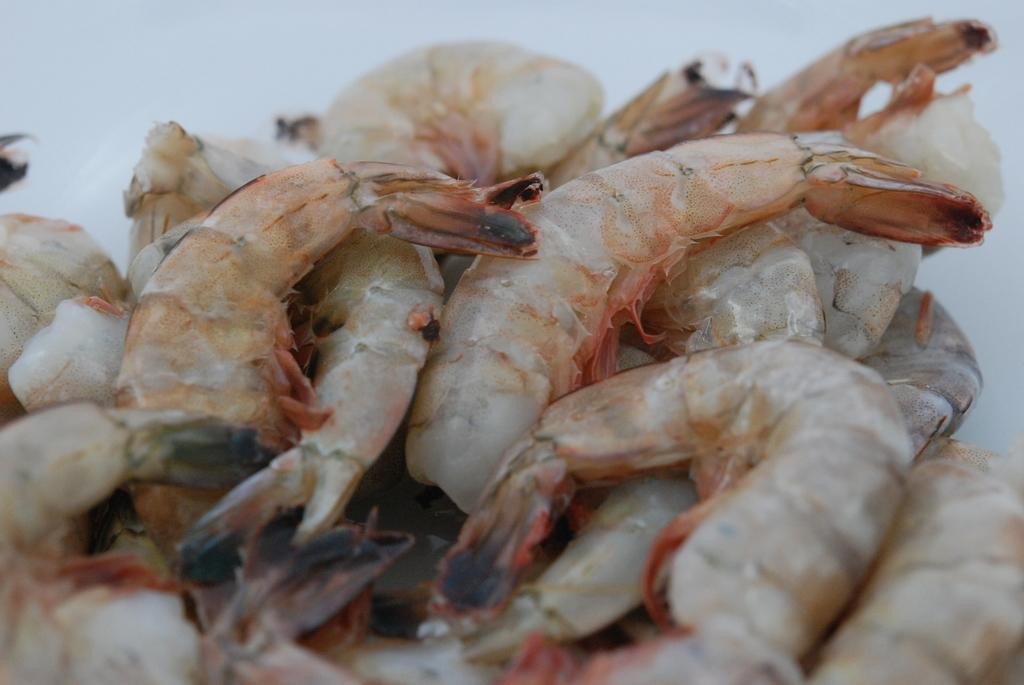What type of seafood is present in the image? There are a few shrimps in the image. Where are the shrimps located in the image? The shrimps are located in the middle of the image. What type of pancake is being offered as a selection in the image? There is no pancake present in the image; it features a few shrimps. What is the desire of the shrimps in the image? The image does not depict the desires of the shrimps, as they are inanimate objects. 